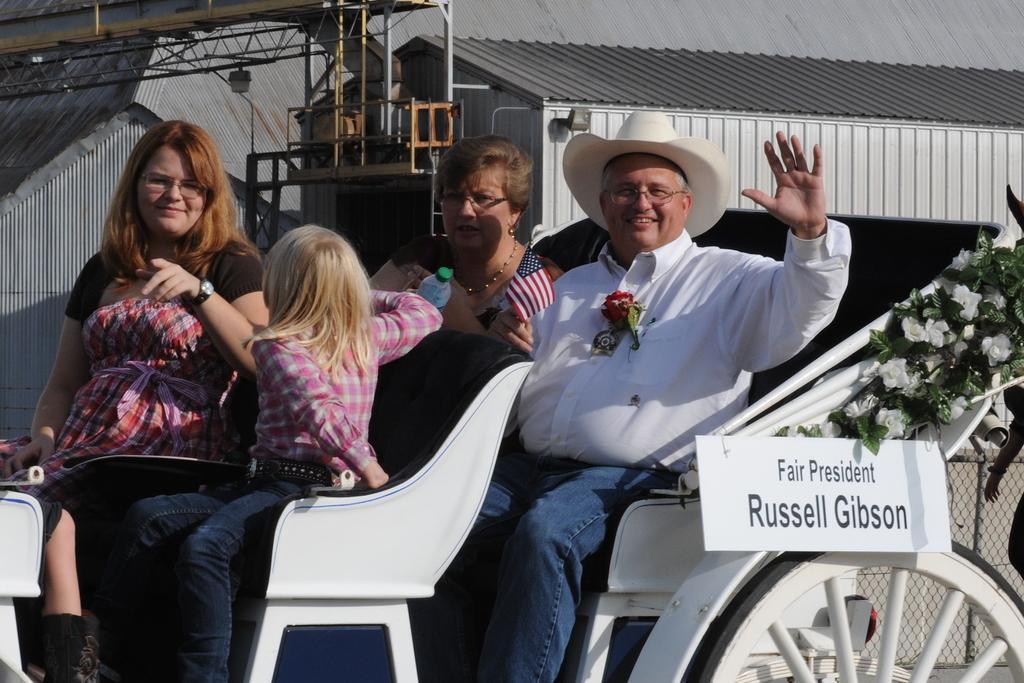In one or two sentences, can you explain what this image depicts? In this image we can see persons, bottle, flag and some other objects. In the background of the image there are iron sheets, lights, iron objects and other objects. On the right side of the image there are leaves, flowers, name board, a person and other objects. 